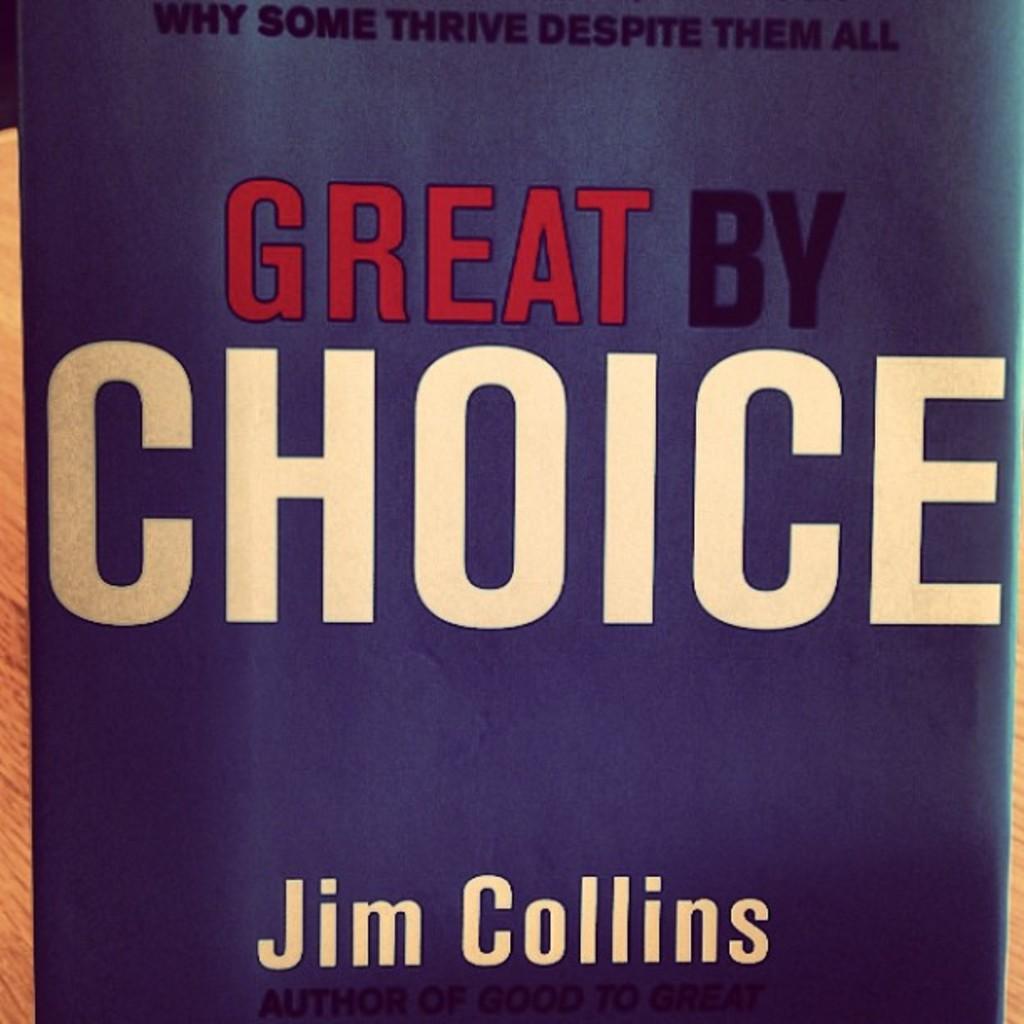What is the title of this book?
Provide a short and direct response. Great by choice. 